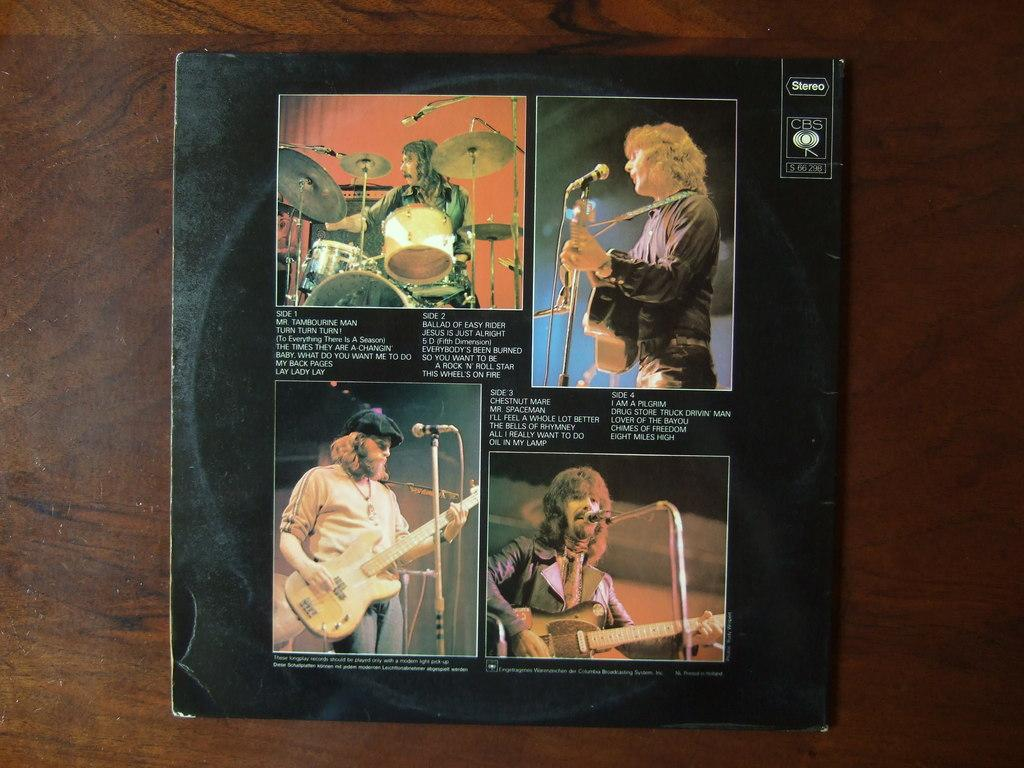<image>
Relay a brief, clear account of the picture shown. Album cover showing four men performing and the letters "CBS" next to it. 